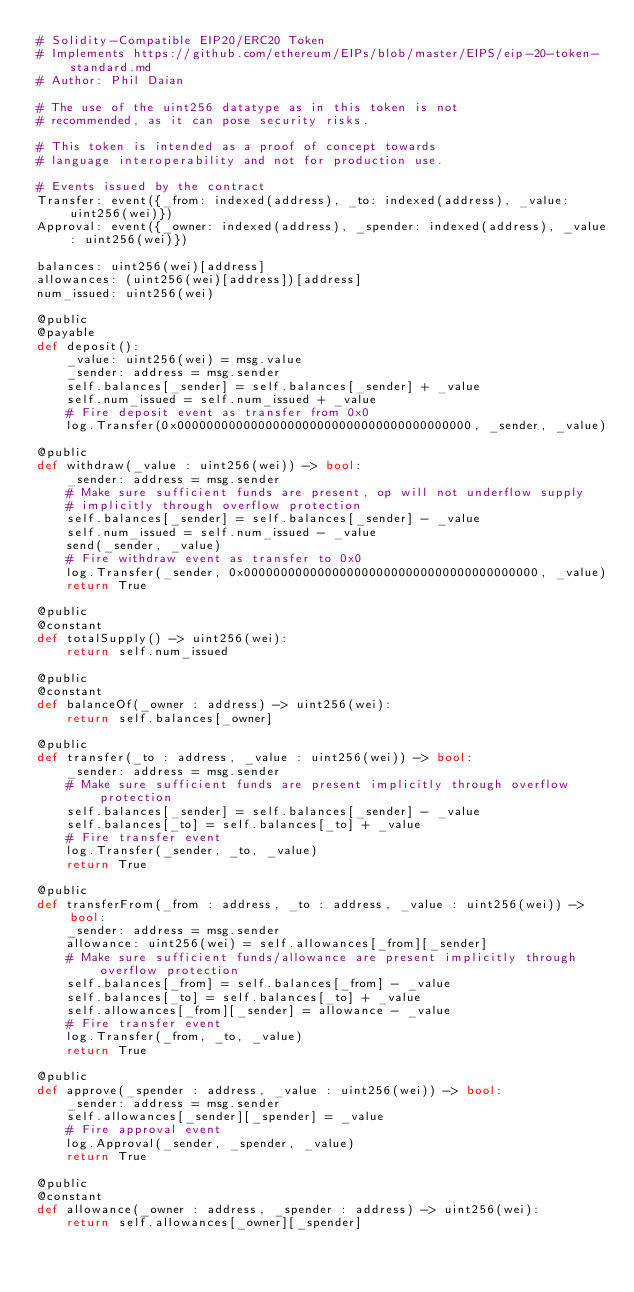Convert code to text. <code><loc_0><loc_0><loc_500><loc_500><_Python_># Solidity-Compatible EIP20/ERC20 Token
# Implements https://github.com/ethereum/EIPs/blob/master/EIPS/eip-20-token-standard.md
# Author: Phil Daian

# The use of the uint256 datatype as in this token is not
# recommended, as it can pose security risks.

# This token is intended as a proof of concept towards
# language interoperability and not for production use.

# Events issued by the contract
Transfer: event({_from: indexed(address), _to: indexed(address), _value: uint256(wei)})
Approval: event({_owner: indexed(address), _spender: indexed(address), _value: uint256(wei)})

balances: uint256(wei)[address]
allowances: (uint256(wei)[address])[address]
num_issued: uint256(wei)

@public
@payable
def deposit():
    _value: uint256(wei) = msg.value
    _sender: address = msg.sender
    self.balances[_sender] = self.balances[_sender] + _value
    self.num_issued = self.num_issued + _value
    # Fire deposit event as transfer from 0x0
    log.Transfer(0x0000000000000000000000000000000000000000, _sender, _value)

@public
def withdraw(_value : uint256(wei)) -> bool:
    _sender: address = msg.sender
    # Make sure sufficient funds are present, op will not underflow supply
    # implicitly through overflow protection
    self.balances[_sender] = self.balances[_sender] - _value
    self.num_issued = self.num_issued - _value
    send(_sender, _value)
    # Fire withdraw event as transfer to 0x0
    log.Transfer(_sender, 0x0000000000000000000000000000000000000000, _value)
    return True

@public
@constant
def totalSupply() -> uint256(wei):
    return self.num_issued

@public
@constant
def balanceOf(_owner : address) -> uint256(wei):
    return self.balances[_owner]

@public
def transfer(_to : address, _value : uint256(wei)) -> bool:
    _sender: address = msg.sender
    # Make sure sufficient funds are present implicitly through overflow protection
    self.balances[_sender] = self.balances[_sender] - _value
    self.balances[_to] = self.balances[_to] + _value
    # Fire transfer event
    log.Transfer(_sender, _to, _value)
    return True

@public
def transferFrom(_from : address, _to : address, _value : uint256(wei)) -> bool:
    _sender: address = msg.sender
    allowance: uint256(wei) = self.allowances[_from][_sender]
    # Make sure sufficient funds/allowance are present implicitly through overflow protection
    self.balances[_from] = self.balances[_from] - _value
    self.balances[_to] = self.balances[_to] + _value
    self.allowances[_from][_sender] = allowance - _value
    # Fire transfer event
    log.Transfer(_from, _to, _value)
    return True

@public
def approve(_spender : address, _value : uint256(wei)) -> bool:
    _sender: address = msg.sender
    self.allowances[_sender][_spender] = _value
    # Fire approval event
    log.Approval(_sender, _spender, _value)
    return True

@public
@constant
def allowance(_owner : address, _spender : address) -> uint256(wei):
    return self.allowances[_owner][_spender]

</code> 